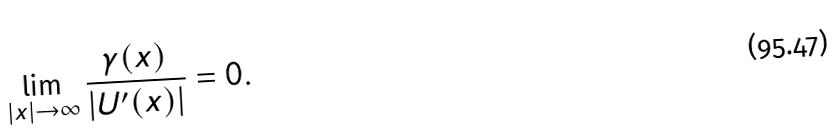Convert formula to latex. <formula><loc_0><loc_0><loc_500><loc_500>\lim _ { | x | \rightarrow \infty } \frac { \gamma ( x ) } { \left | U ^ { \prime } ( x ) \right | } = 0 .</formula> 